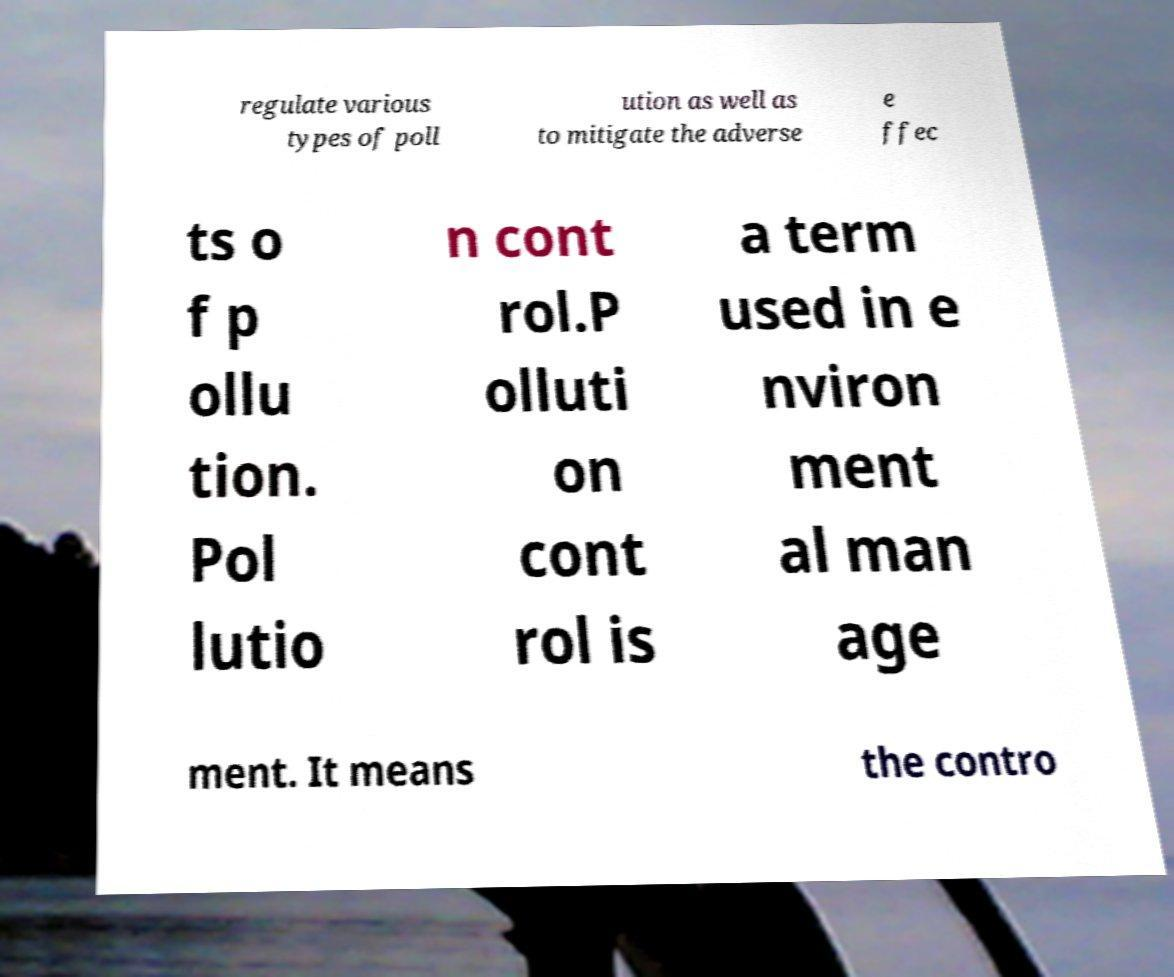Can you read and provide the text displayed in the image?This photo seems to have some interesting text. Can you extract and type it out for me? regulate various types of poll ution as well as to mitigate the adverse e ffec ts o f p ollu tion. Pol lutio n cont rol.P olluti on cont rol is a term used in e nviron ment al man age ment. It means the contro 